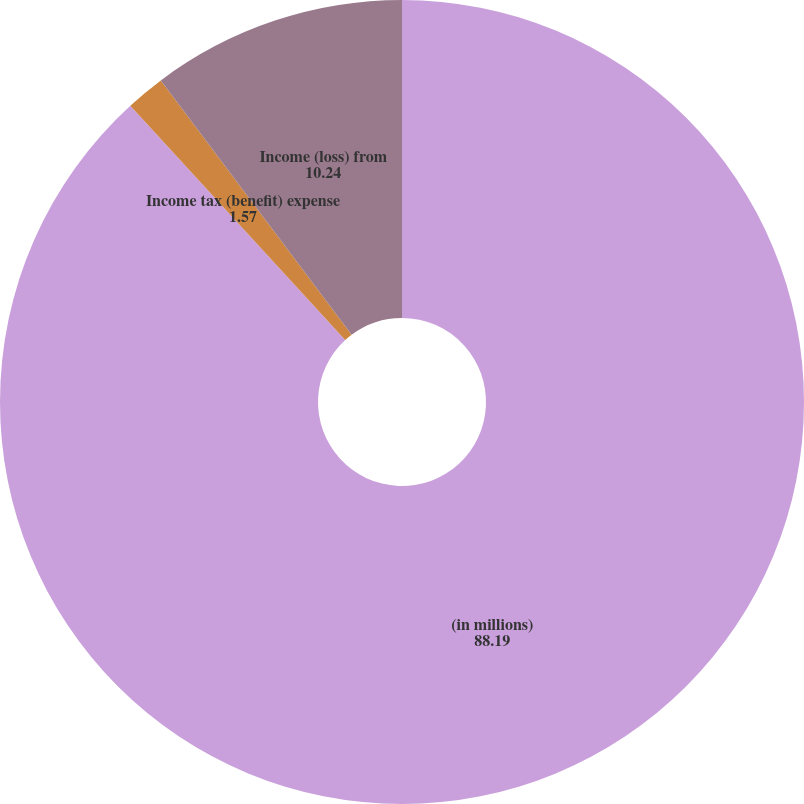<chart> <loc_0><loc_0><loc_500><loc_500><pie_chart><fcel>(in millions)<fcel>Income tax (benefit) expense<fcel>Income (loss) from<nl><fcel>88.19%<fcel>1.57%<fcel>10.24%<nl></chart> 